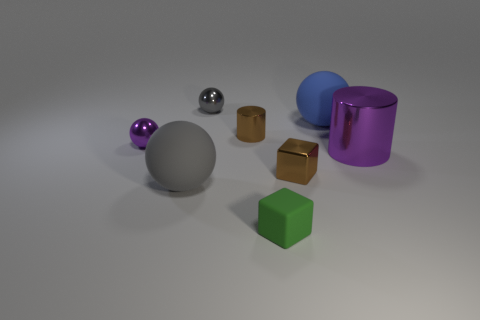Can you describe the different materials that the objects in the image seem to be made from? Certainly! The objects in the image display a variety of textures suggesting different materials. The spheres seem to have a matte finish, possibly rubber or plastic, while the cubes bear a more reflective finish and could be metallic. The cylindrical objects exhibit shiny surfaces, indicating they might be made of metal or a high-gloss plastic. 